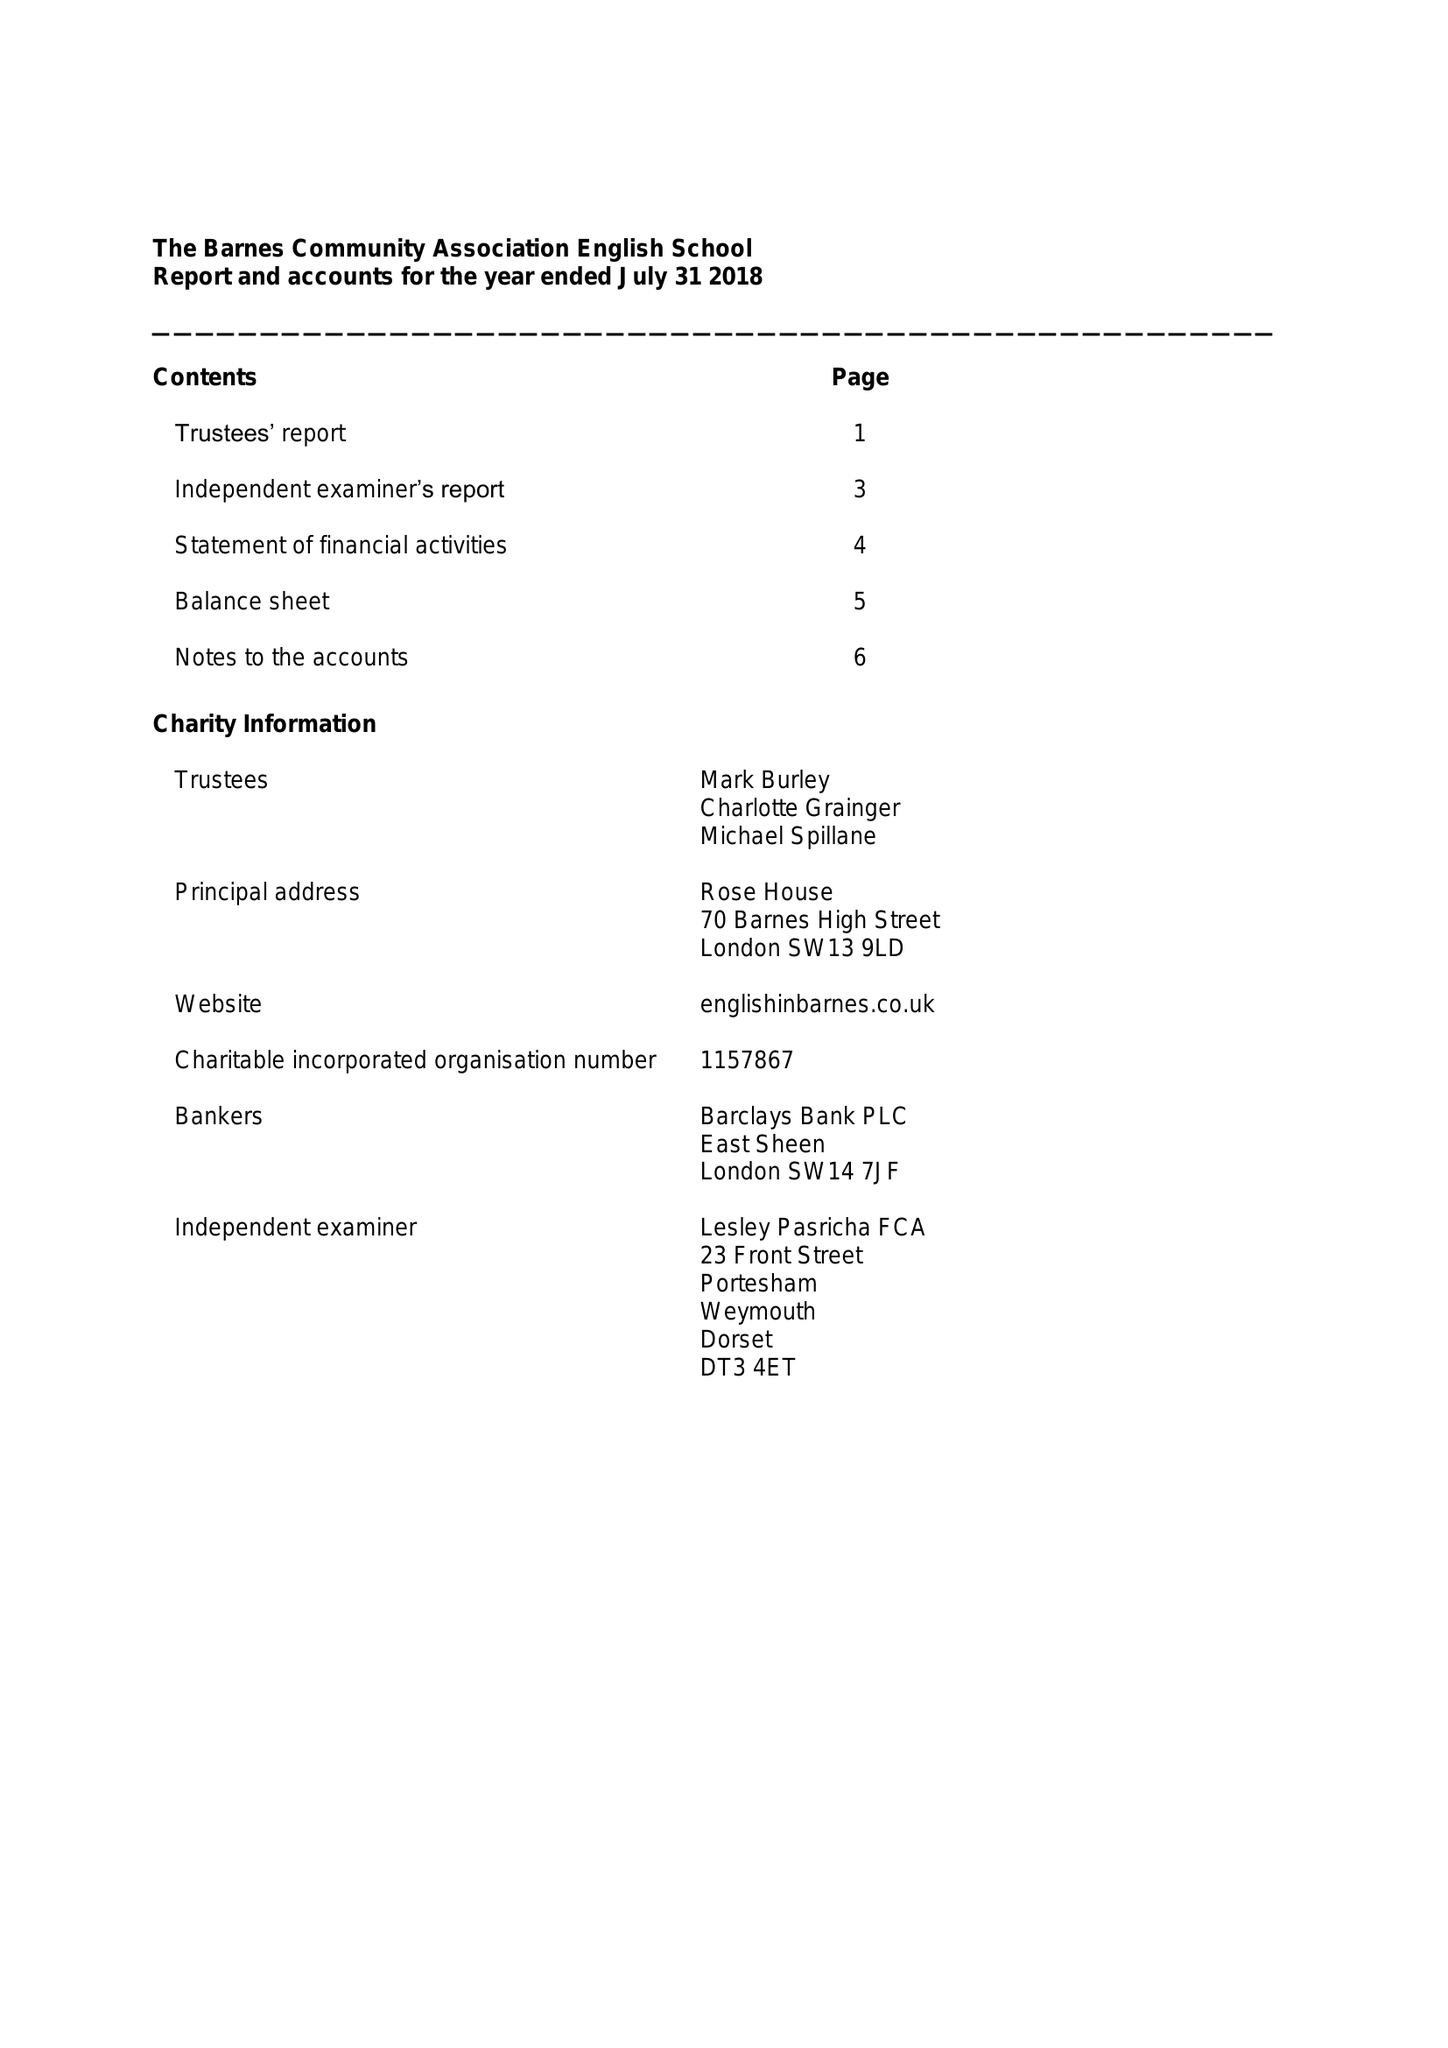What is the value for the report_date?
Answer the question using a single word or phrase. 2018-07-31 